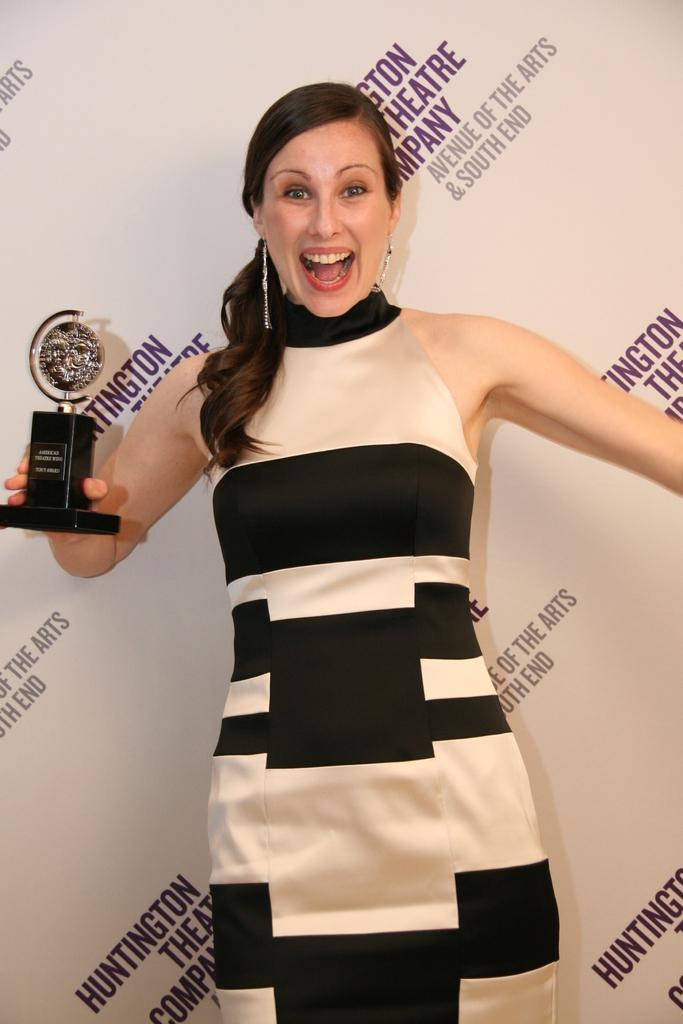Provide a one-sentence caption for the provided image. A woman in a dress holds an award in front of a banner reading Huntington Theatre Company. 